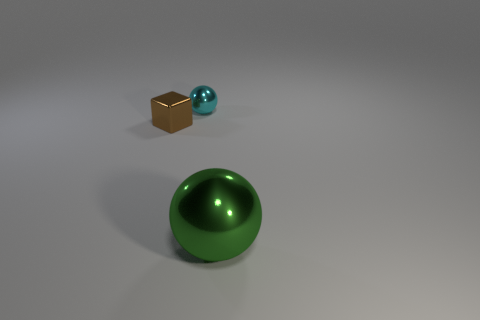Subtract all red blocks. Subtract all green cylinders. How many blocks are left? 1 Add 1 shiny blocks. How many objects exist? 4 Subtract all balls. How many objects are left? 1 Add 1 brown metallic blocks. How many brown metallic blocks exist? 2 Subtract 1 green balls. How many objects are left? 2 Subtract all metal things. Subtract all tiny cyan cubes. How many objects are left? 0 Add 1 spheres. How many spheres are left? 3 